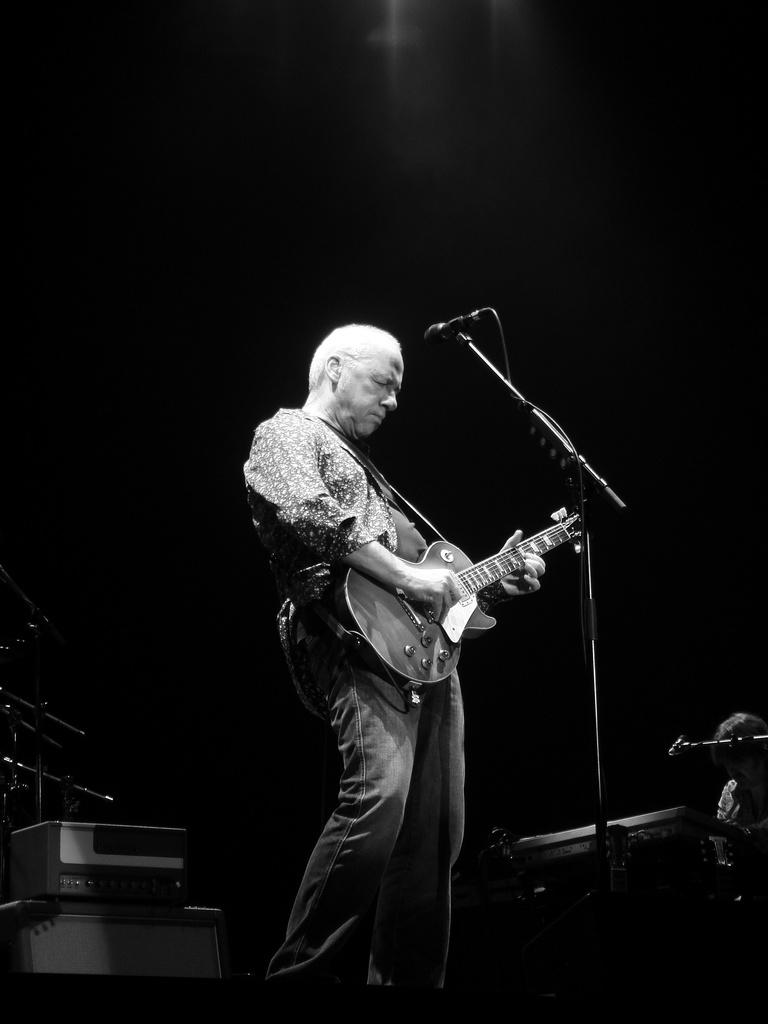Who is the main subject in the image? There is a man in the image. What is the man doing in the image? The man is standing in front of a microphone and playing a guitar. Are there any other musical instruments visible in the image? Yes, there are musical instruments visible in the background of the image. What type of worm can be seen crawling on the guitar in the image? There is no worm present in the image; the guitar is being played by the man. What kind of plant is growing near the microphone in the image? There is no plant visible in the image; the focus is on the man and his musical instruments. 